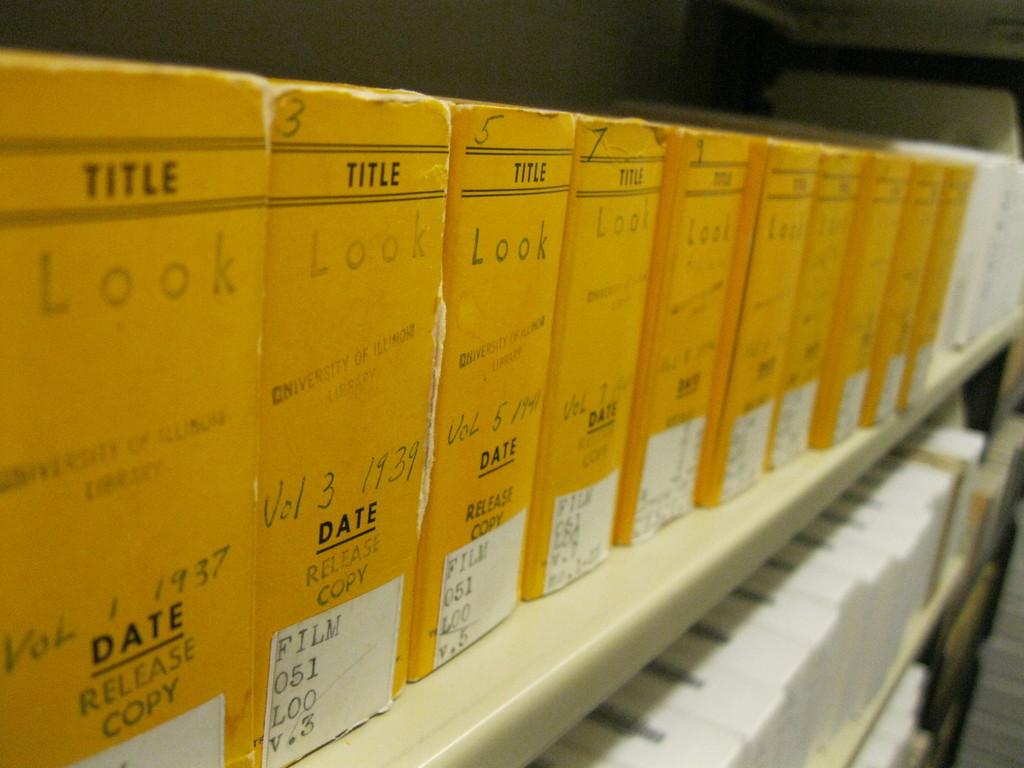What is the release year of vol 1?
Offer a terse response. 1937. What is the title of these volumes?
Keep it short and to the point. Look. 